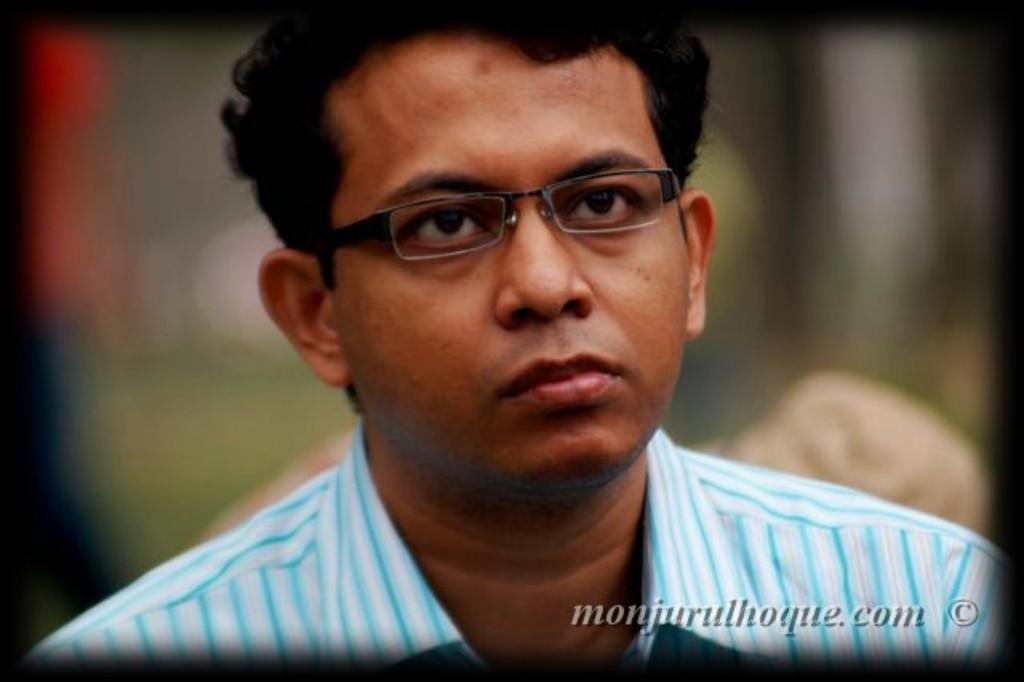Who or what is the main subject of the image? There is a person in the image. What can be observed about the person's appearance? The person is wearing glasses (specs). Can you describe the background of the image? The background of the image is blurred. Is there any text present in the image? Yes, there is text on the image. What type of expansion is being demonstrated by the key in the image? There is no key present in the image, so expansion cannot be observed or discussed. 